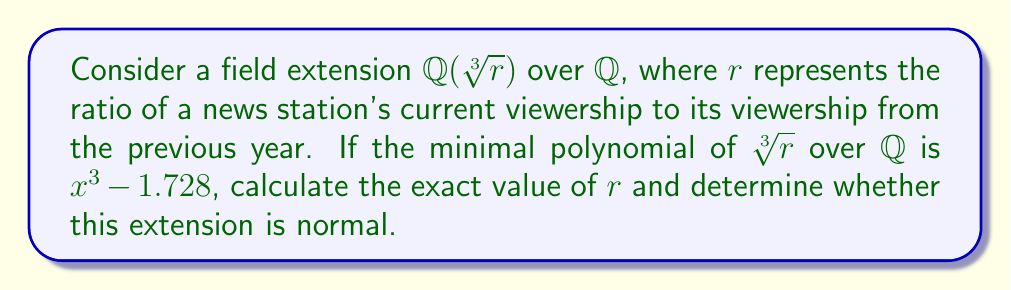What is the answer to this math problem? 1) Given the minimal polynomial $x^3 - 1.728$, we can identify that $r = 1.728$.

2) To determine if the extension is normal, we need to find all roots of the minimal polynomial:

   $x^3 - 1.728 = 0$
   $x^3 = 1.728$
   $x = \sqrt[3]{1.728}$

3) The three cube roots of 1.728 are:
   $\sqrt[3]{1.728}$
   $\sqrt[3]{1.728} \cdot \omega$
   $\sqrt[3]{1.728} \cdot \omega^2$

   Where $\omega = e^{2\pi i/3} = -\frac{1}{2} + i\frac{\sqrt{3}}{2}$ is a primitive cube root of unity.

4) For the extension to be normal, all these roots must be in $\mathbb{Q}(\sqrt[3]{1.728})$.

5) However, $\omega$ and $\omega^2$ are not in $\mathbb{Q}(\sqrt[3]{1.728})$, as they involve complex numbers.

6) Therefore, $\mathbb{Q}(\sqrt[3]{1.728})$ is not a normal extension over $\mathbb{Q}$.
Answer: $r = 1.728$; Not normal 